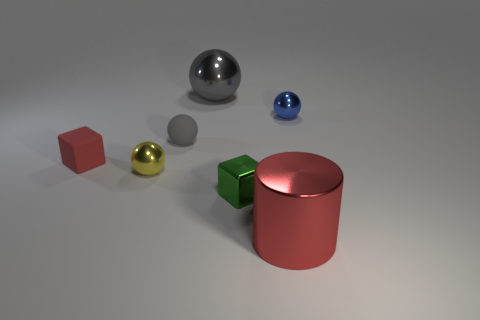Subtract all purple blocks. How many gray spheres are left? 2 Add 1 yellow matte things. How many objects exist? 8 Subtract all small yellow spheres. How many spheres are left? 3 Subtract 2 spheres. How many spheres are left? 2 Subtract all gray balls. How many balls are left? 2 Subtract all cylinders. How many objects are left? 6 Add 4 large red metal objects. How many large red metal objects are left? 5 Add 1 big cylinders. How many big cylinders exist? 2 Subtract 0 gray blocks. How many objects are left? 7 Subtract all blue spheres. Subtract all gray cylinders. How many spheres are left? 3 